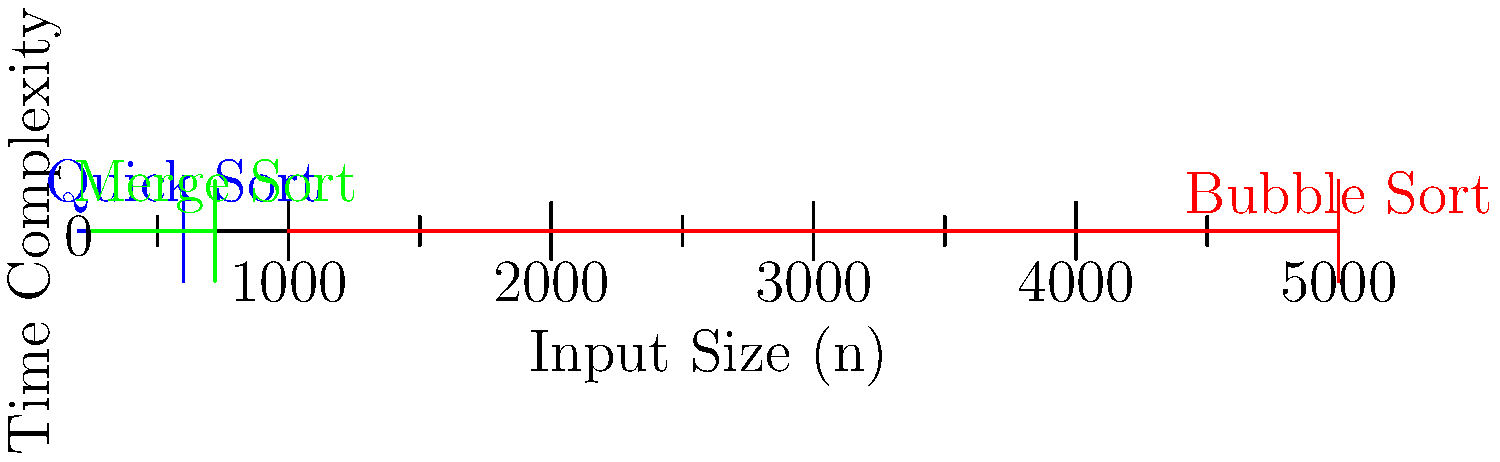Based on the bar graph showing the time complexity of Quick Sort, Merge Sort, and Bubble Sort for different input sizes, which sorting algorithm demonstrates the worst efficiency for large datasets? Justify your answer using the asymptotic time complexity of each algorithm. To answer this question, we need to analyze the growth rates of the time complexities shown in the graph and relate them to the known asymptotic time complexities of the sorting algorithms:

1. Quick Sort (blue):
   - Shows a relatively slow growth rate
   - Known average-case time complexity: $O(n \log n)$

2. Merge Sort (green):
   - Shows a slightly faster growth rate than Quick Sort
   - Known time complexity: $O(n \log n)$

3. Bubble Sort (red):
   - Shows a significantly faster growth rate compared to the other two
   - Known time complexity: $O(n^2)$

Analyzing the graph:
- The y-axis represents time complexity, and the x-axis represents input size (n).
- As n increases, Bubble Sort's time complexity grows much more rapidly than Quick Sort and Merge Sort.
- This rapid growth aligns with Bubble Sort's $O(n^2)$ time complexity, which is quadratic.
- Quick Sort and Merge Sort show similar, much slower growth rates, consistent with their $O(n \log n)$ time complexities.

Therefore, Bubble Sort demonstrates the worst efficiency for large datasets because its time complexity grows quadratically with the input size, while Quick Sort and Merge Sort grow at a slower, linearithmic rate.
Answer: Bubble Sort, due to its $O(n^2)$ time complexity. 